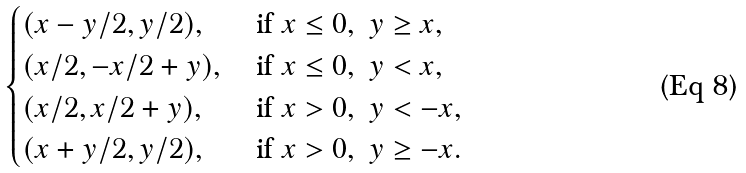Convert formula to latex. <formula><loc_0><loc_0><loc_500><loc_500>\begin{cases} ( x - y / 2 , y / 2 ) , \, & \text {if } x \leq 0 , \ y \geq x , \\ ( x / 2 , - x / 2 + y ) , \, & \text {if } x \leq 0 , \ y < x , \\ ( x / 2 , x / 2 + y ) , \, & \text {if } x > 0 , \ y < - x , \\ ( x + y / 2 , y / 2 ) , \, & \text {if } x > 0 , \ y \geq - x . \end{cases}</formula> 